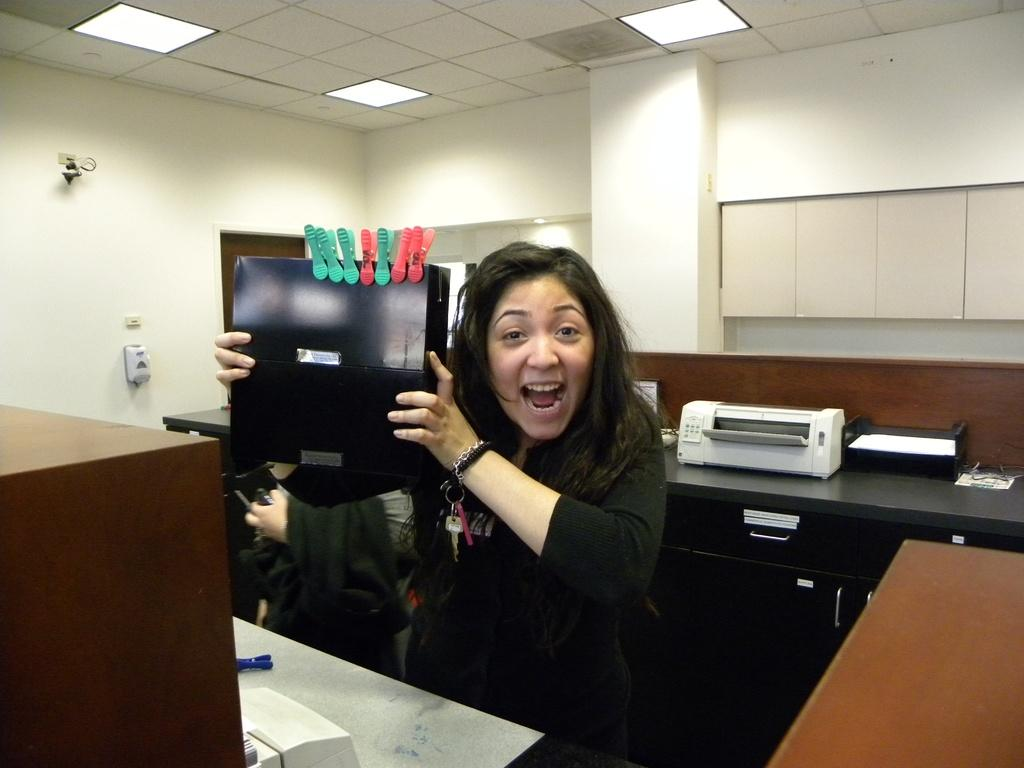Who is present in the image? There is a woman in the image. What is the woman holding in her hand? The woman is holding a box in her hand. Can you describe the box? The box has clips on it. What can be seen in the background of the image? There is a printer visible in the background of the image. What type of hat is the woman wearing in the image? There is no hat visible in the image; the woman is not wearing a hat. 